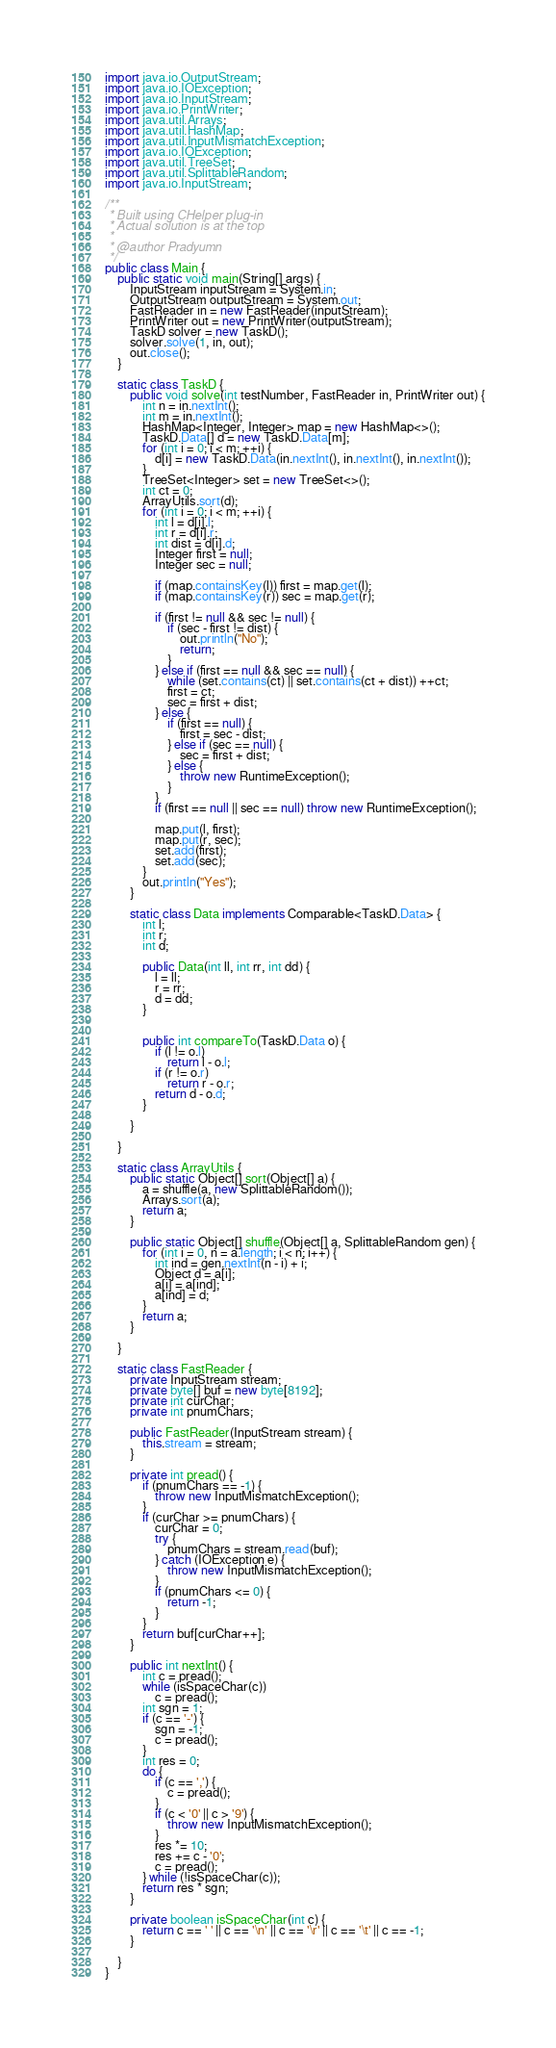Convert code to text. <code><loc_0><loc_0><loc_500><loc_500><_Java_>import java.io.OutputStream;
import java.io.IOException;
import java.io.InputStream;
import java.io.PrintWriter;
import java.util.Arrays;
import java.util.HashMap;
import java.util.InputMismatchException;
import java.io.IOException;
import java.util.TreeSet;
import java.util.SplittableRandom;
import java.io.InputStream;

/**
 * Built using CHelper plug-in
 * Actual solution is at the top
 *
 * @author Pradyumn
 */
public class Main {
    public static void main(String[] args) {
        InputStream inputStream = System.in;
        OutputStream outputStream = System.out;
        FastReader in = new FastReader(inputStream);
        PrintWriter out = new PrintWriter(outputStream);
        TaskD solver = new TaskD();
        solver.solve(1, in, out);
        out.close();
    }

    static class TaskD {
        public void solve(int testNumber, FastReader in, PrintWriter out) {
            int n = in.nextInt();
            int m = in.nextInt();
            HashMap<Integer, Integer> map = new HashMap<>();
            TaskD.Data[] d = new TaskD.Data[m];
            for (int i = 0; i < m; ++i) {
                d[i] = new TaskD.Data(in.nextInt(), in.nextInt(), in.nextInt());
            }
            TreeSet<Integer> set = new TreeSet<>();
            int ct = 0;
            ArrayUtils.sort(d);
            for (int i = 0; i < m; ++i) {
                int l = d[i].l;
                int r = d[i].r;
                int dist = d[i].d;
                Integer first = null;
                Integer sec = null;

                if (map.containsKey(l)) first = map.get(l);
                if (map.containsKey(r)) sec = map.get(r);

                if (first != null && sec != null) {
                    if (sec - first != dist) {
                        out.println("No");
                        return;
                    }
                } else if (first == null && sec == null) {
                    while (set.contains(ct) || set.contains(ct + dist)) ++ct;
                    first = ct;
                    sec = first + dist;
                } else {
                    if (first == null) {
                        first = sec - dist;
                    } else if (sec == null) {
                        sec = first + dist;
                    } else {
                        throw new RuntimeException();
                    }
                }
                if (first == null || sec == null) throw new RuntimeException();

                map.put(l, first);
                map.put(r, sec);
                set.add(first);
                set.add(sec);
            }
            out.println("Yes");
        }

        static class Data implements Comparable<TaskD.Data> {
            int l;
            int r;
            int d;

            public Data(int ll, int rr, int dd) {
                l = ll;
                r = rr;
                d = dd;
            }


            public int compareTo(TaskD.Data o) {
                if (l != o.l)
                    return l - o.l;
                if (r != o.r)
                    return r - o.r;
                return d - o.d;
            }

        }

    }

    static class ArrayUtils {
        public static Object[] sort(Object[] a) {
            a = shuffle(a, new SplittableRandom());
            Arrays.sort(a);
            return a;
        }

        public static Object[] shuffle(Object[] a, SplittableRandom gen) {
            for (int i = 0, n = a.length; i < n; i++) {
                int ind = gen.nextInt(n - i) + i;
                Object d = a[i];
                a[i] = a[ind];
                a[ind] = d;
            }
            return a;
        }

    }

    static class FastReader {
        private InputStream stream;
        private byte[] buf = new byte[8192];
        private int curChar;
        private int pnumChars;

        public FastReader(InputStream stream) {
            this.stream = stream;
        }

        private int pread() {
            if (pnumChars == -1) {
                throw new InputMismatchException();
            }
            if (curChar >= pnumChars) {
                curChar = 0;
                try {
                    pnumChars = stream.read(buf);
                } catch (IOException e) {
                    throw new InputMismatchException();
                }
                if (pnumChars <= 0) {
                    return -1;
                }
            }
            return buf[curChar++];
        }

        public int nextInt() {
            int c = pread();
            while (isSpaceChar(c))
                c = pread();
            int sgn = 1;
            if (c == '-') {
                sgn = -1;
                c = pread();
            }
            int res = 0;
            do {
                if (c == ',') {
                    c = pread();
                }
                if (c < '0' || c > '9') {
                    throw new InputMismatchException();
                }
                res *= 10;
                res += c - '0';
                c = pread();
            } while (!isSpaceChar(c));
            return res * sgn;
        }

        private boolean isSpaceChar(int c) {
            return c == ' ' || c == '\n' || c == '\r' || c == '\t' || c == -1;
        }

    }
}

</code> 